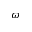Convert formula to latex. <formula><loc_0><loc_0><loc_500><loc_500>\omega</formula> 